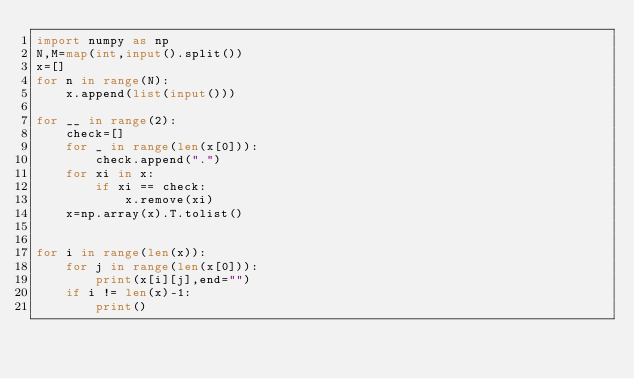<code> <loc_0><loc_0><loc_500><loc_500><_Python_>import numpy as np
N,M=map(int,input().split())
x=[]
for n in range(N):
	x.append(list(input()))

for __ in range(2):
	check=[]
	for _ in range(len(x[0])):
		check.append(".")
	for xi in x:
		if xi == check:
			x.remove(xi)
	x=np.array(x).T.tolist()


for i in range(len(x)):
	for j in range(len(x[0])):
		print(x[i][j],end="")
	if i != len(x)-1:
		print()</code> 